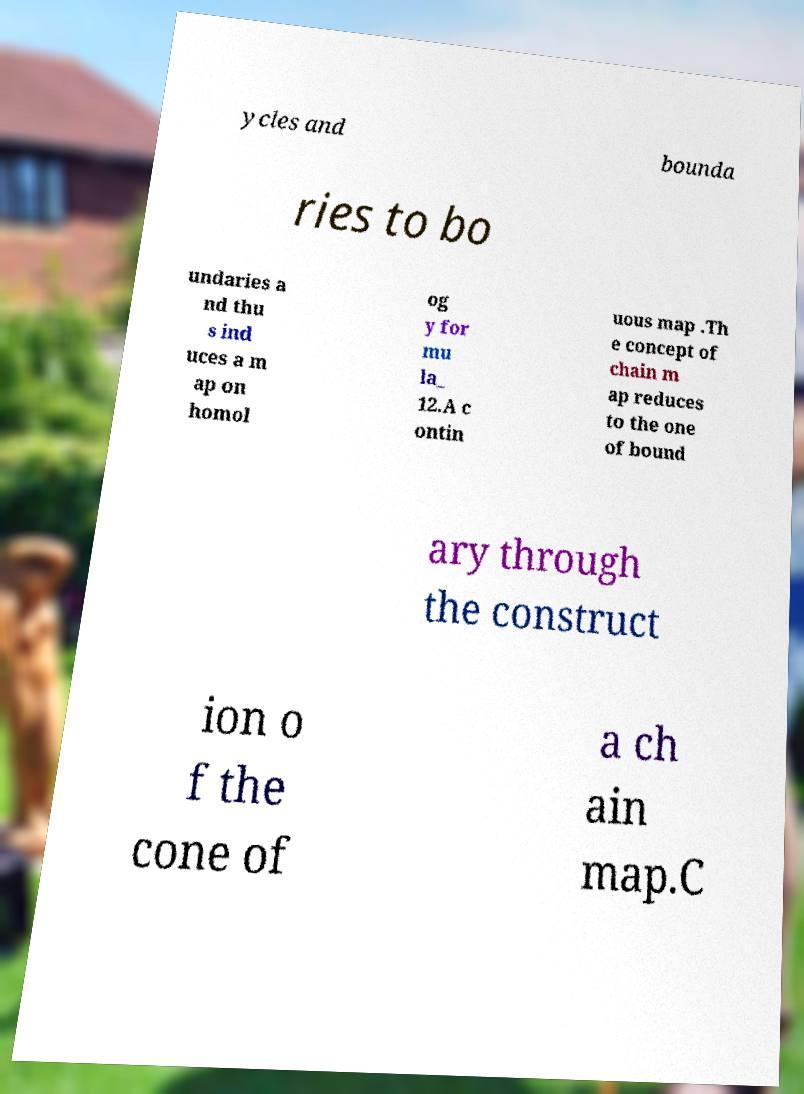For documentation purposes, I need the text within this image transcribed. Could you provide that? ycles and bounda ries to bo undaries a nd thu s ind uces a m ap on homol og y for mu la_ 12.A c ontin uous map .Th e concept of chain m ap reduces to the one of bound ary through the construct ion o f the cone of a ch ain map.C 